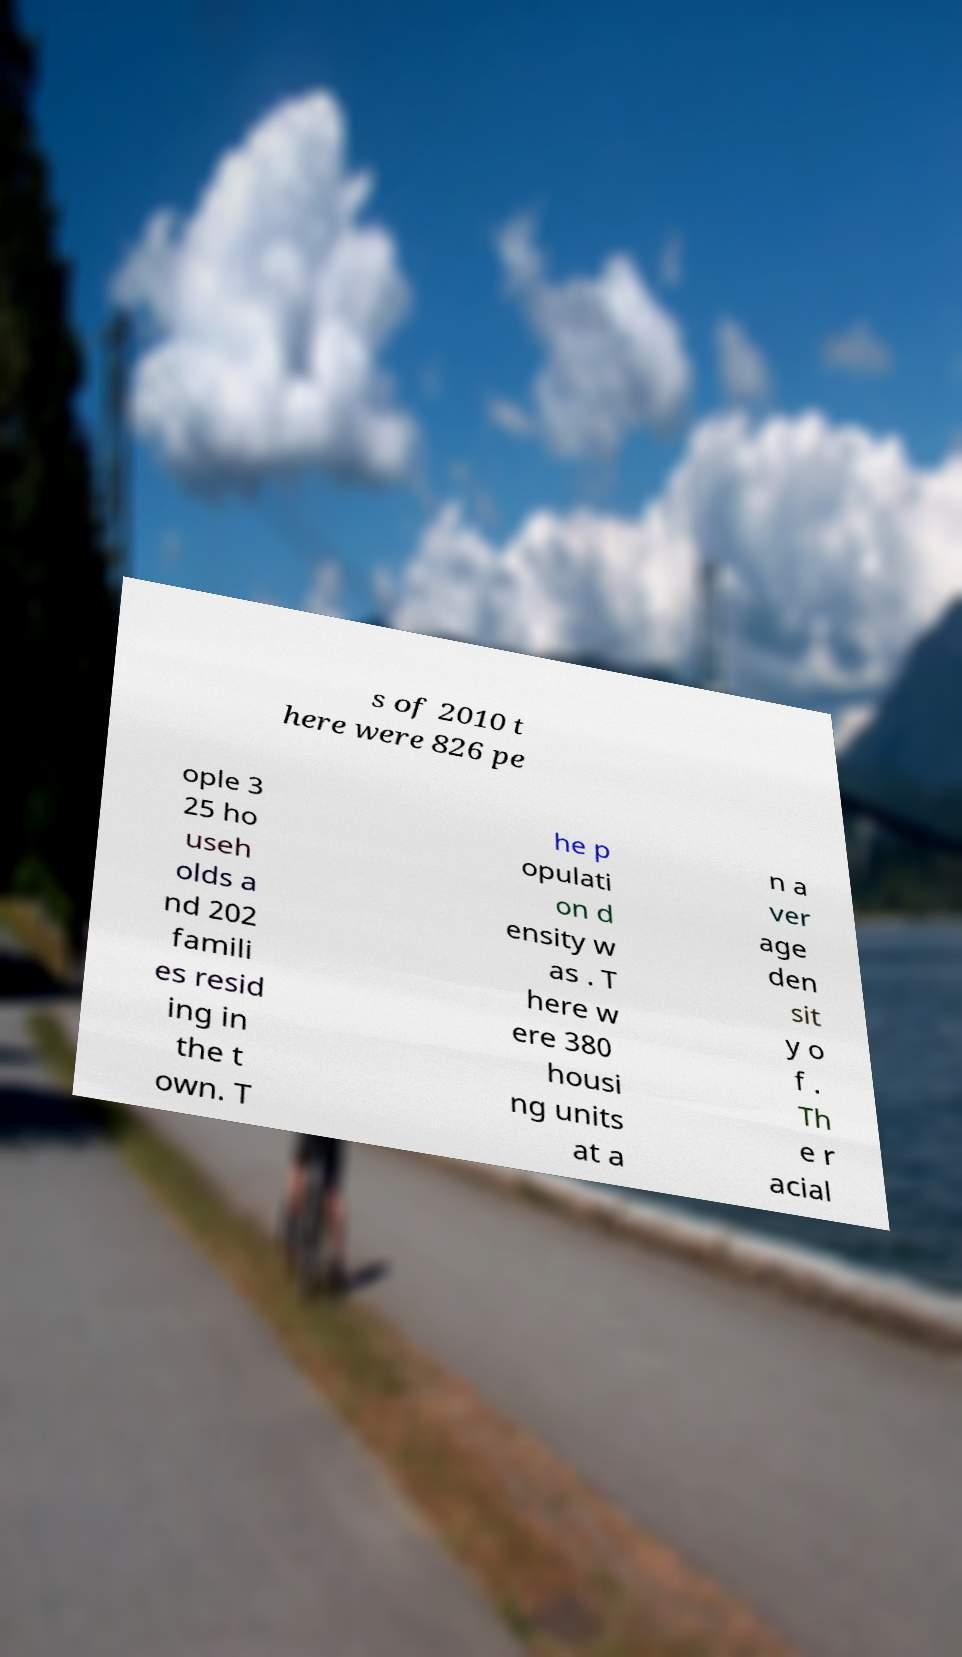Could you assist in decoding the text presented in this image and type it out clearly? s of 2010 t here were 826 pe ople 3 25 ho useh olds a nd 202 famili es resid ing in the t own. T he p opulati on d ensity w as . T here w ere 380 housi ng units at a n a ver age den sit y o f . Th e r acial 